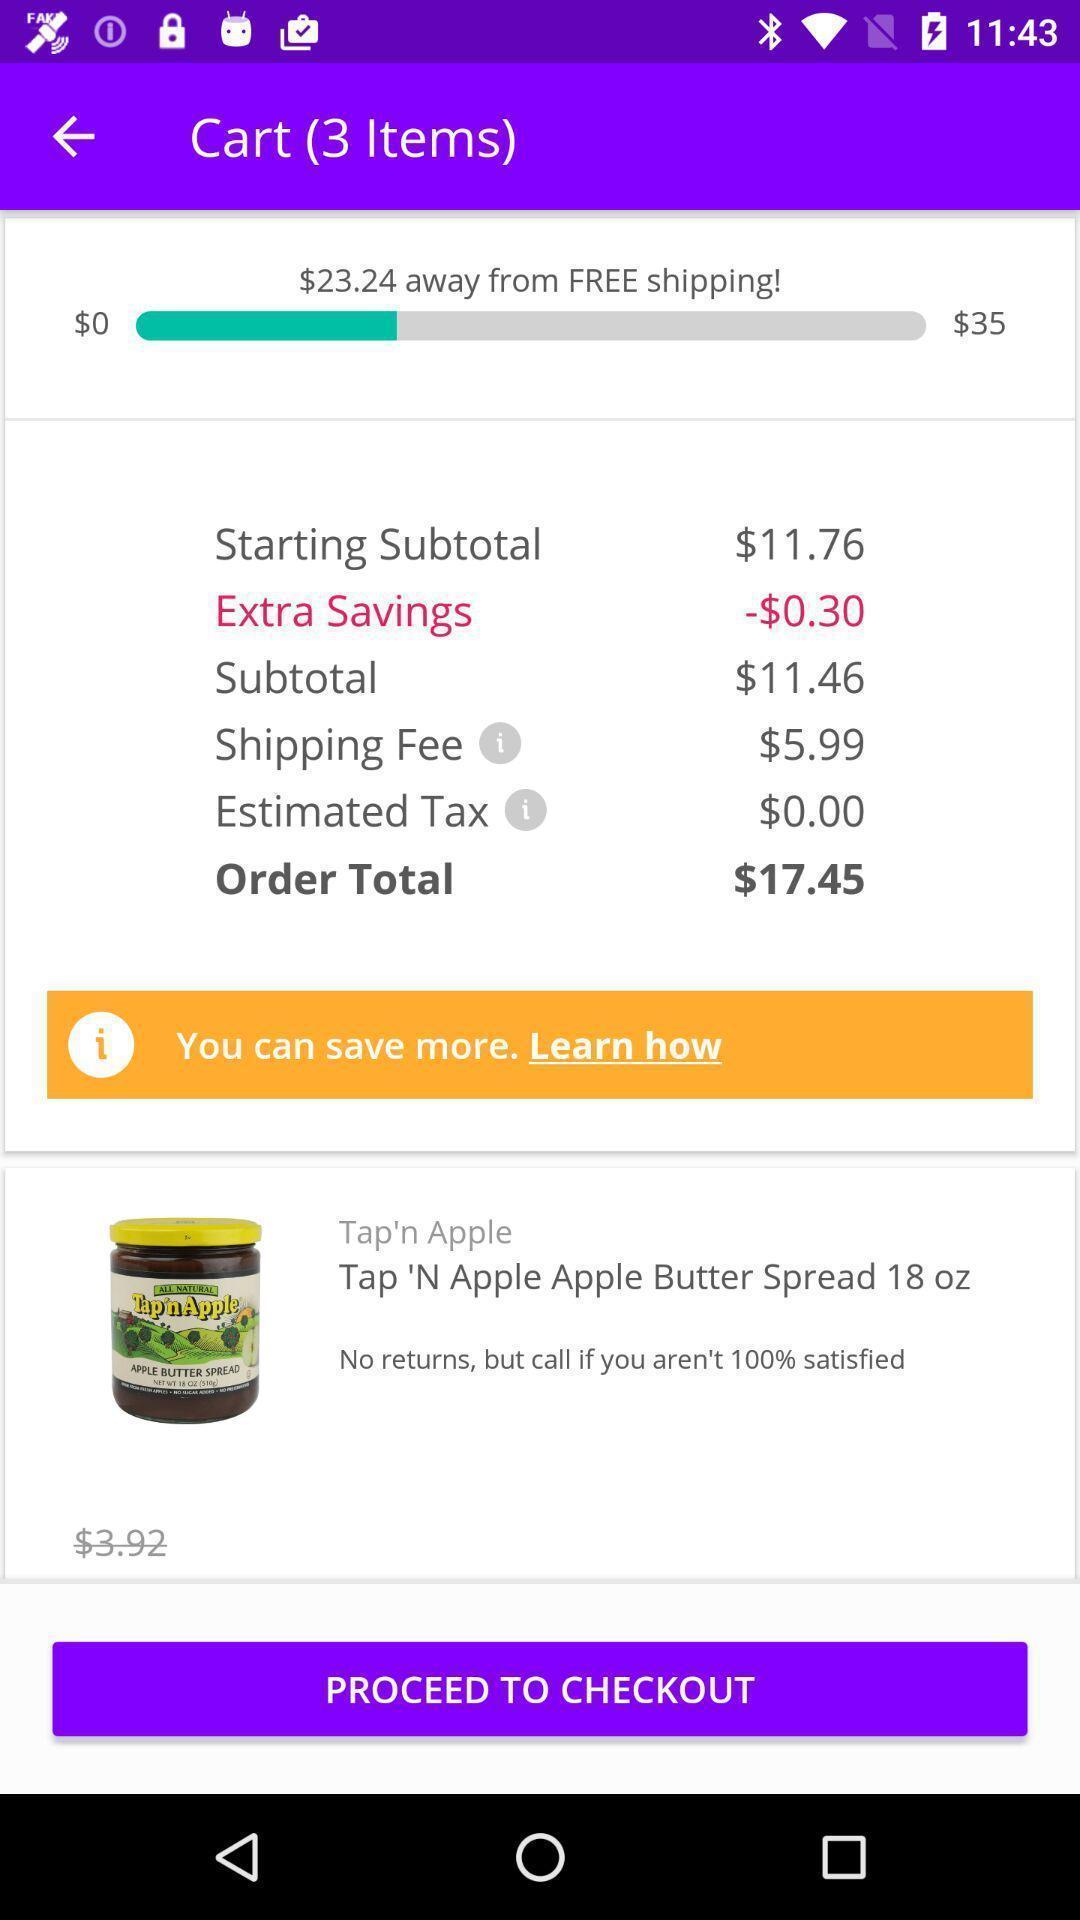What is the overall content of this screenshot? Shopping page showing delivery details. 